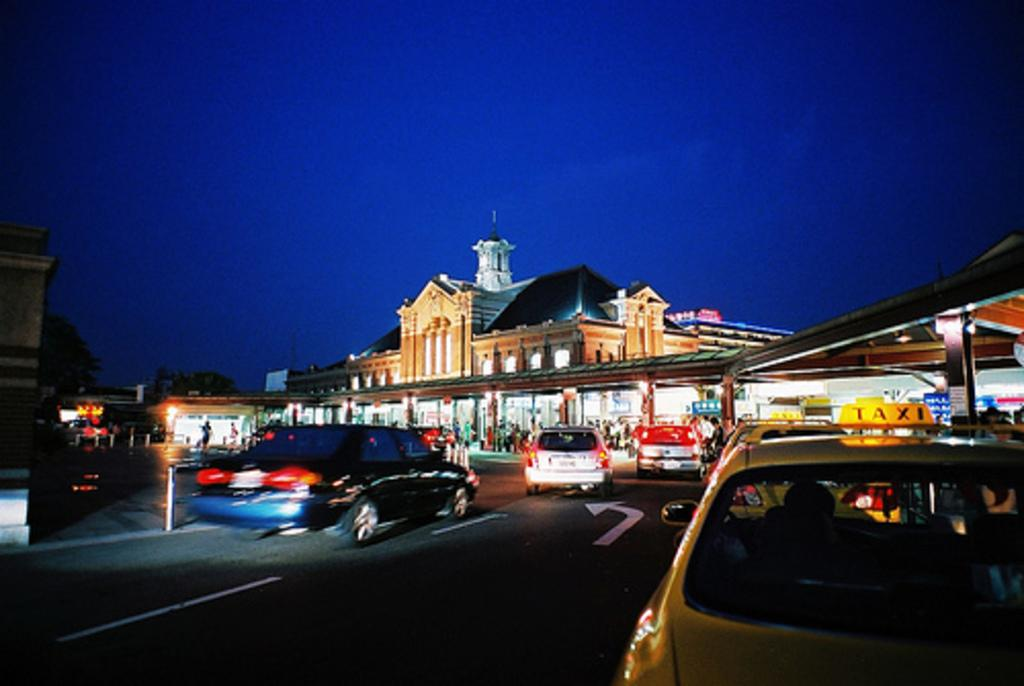<image>
Provide a brief description of the given image. A dark street with a yellow vehicle bearing the word Taxi. 